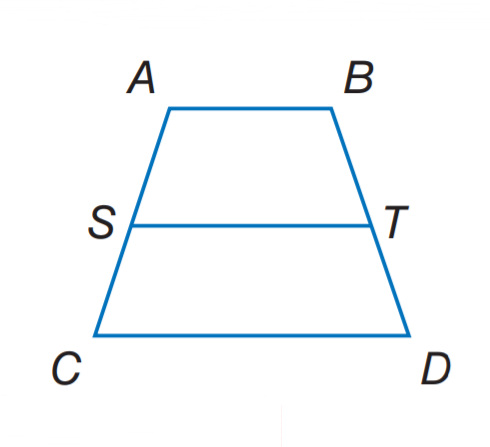Answer the mathemtical geometry problem and directly provide the correct option letter.
Question: For trapezoid A B C D, S and T are midpoints of the legs. If A B = 3 x, S T = 15, and C D = 9 x, find x.
Choices: A: 2.5 B: 3 C: 3.5 D: 5 A 